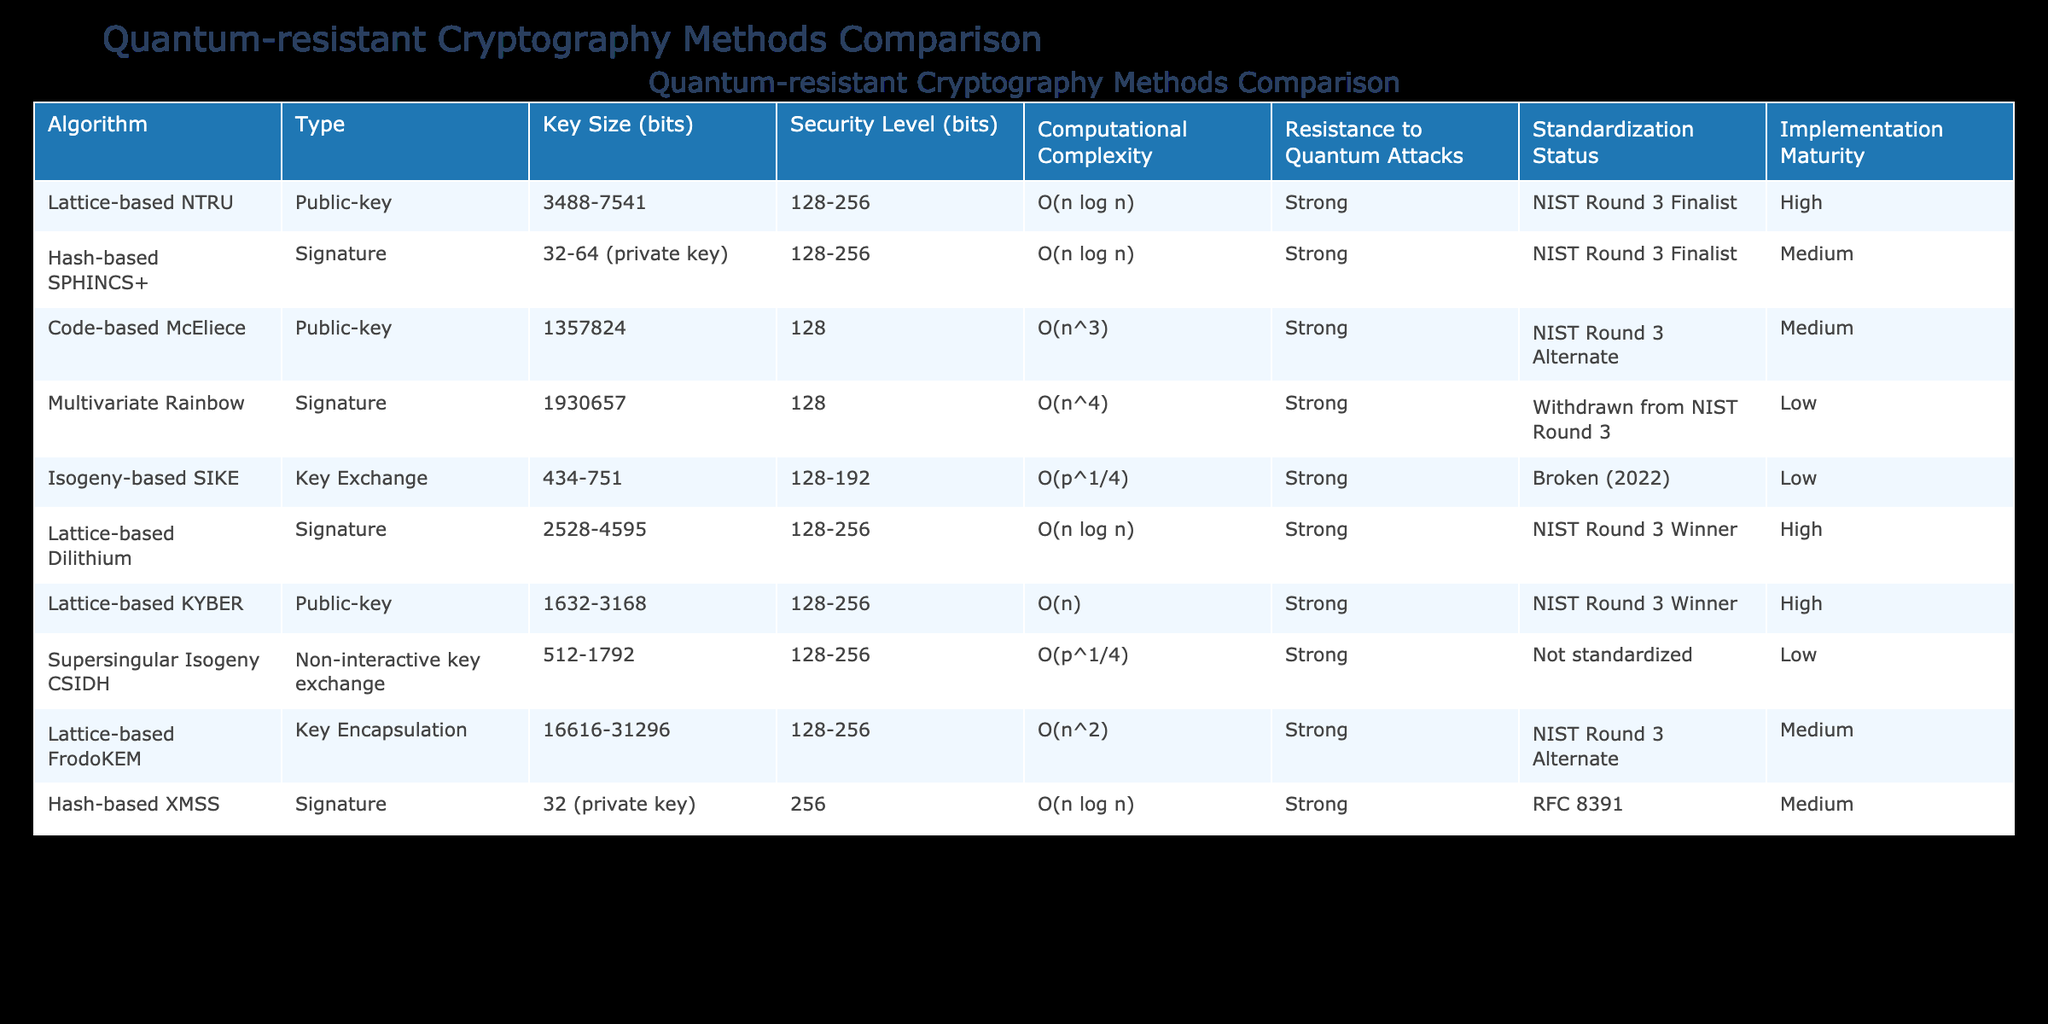What is the key size range of the Lattice-based KYBER algorithm? From the table, the Lattice-based KYBER algorithm has a key size range of 1632-3168 bits as noted in the Key Size (bits) column.
Answer: 1632-3168 bits How many quantum-resistant algorithms have a medium implementation maturity? Referring to the Implementation Maturity column, the algorithms with medium implementation maturity are Hash-based SPHINCS+, Code-based McEliece, Lattice-based FrodoKEM, and Hash-based XMSS. This results in a total of 4 algorithms.
Answer: 4 Is the Isogeny-based SIKE algorithm considered strong against quantum attacks? In the Resistance to Quantum Attacks column, the Isogeny-based SIKE algorithm is marked as "Broken (2022)", indicating it is not considered strong against quantum attacks.
Answer: No What is the average security level (in bits) for algorithms that have high implementation maturity? The algorithms with high implementation maturity are Lattice-based NTRU, Lattice-based Dilithium, and Lattice-based KYBER. Their security levels are 128, 256, and 256 bits respectively. The average security level is calculated as (128 + 256 + 256) / 3 = 213.33. Therefore, the average security level for these algorithms is approximately 213.33 bits.
Answer: 213.33 Which algorithm has the largest key size and what is that size? In the Key Size (bits) column, the Code-based McEliece algorithm has the largest key size listed at 1357824 bits.
Answer: 1357824 bits How many algorithms are included in the NIST Round 3 Finalist status? The algorithms that were finalists in the NIST Round 3 are Lattice-based NTRU, Hash-based SPHINCS+, Lattice-based Dilithium, and Lattice-based KYBER. Counting these gives us a total of 4 algorithms.
Answer: 4 Is the Multivariate Rainbow algorithm still being considered for NIST standards? According to the Standardization Status column, the Multivariate Rainbow algorithm has been withdrawn from NIST Round 3, indicating it is not currently considered for standardization.
Answer: No Which algorithm has the lowest resistance to quantum attacks? In the Resistance to Quantum Attacks column, the Isogeny-based SIKE and Multivariate Rainbow algorithms are marked as "Low", but since Isogeny-based SIKE is noted as "Broken (2022)", it indicates it has the lowest resistance.
Answer: Isogeny-based SIKE 